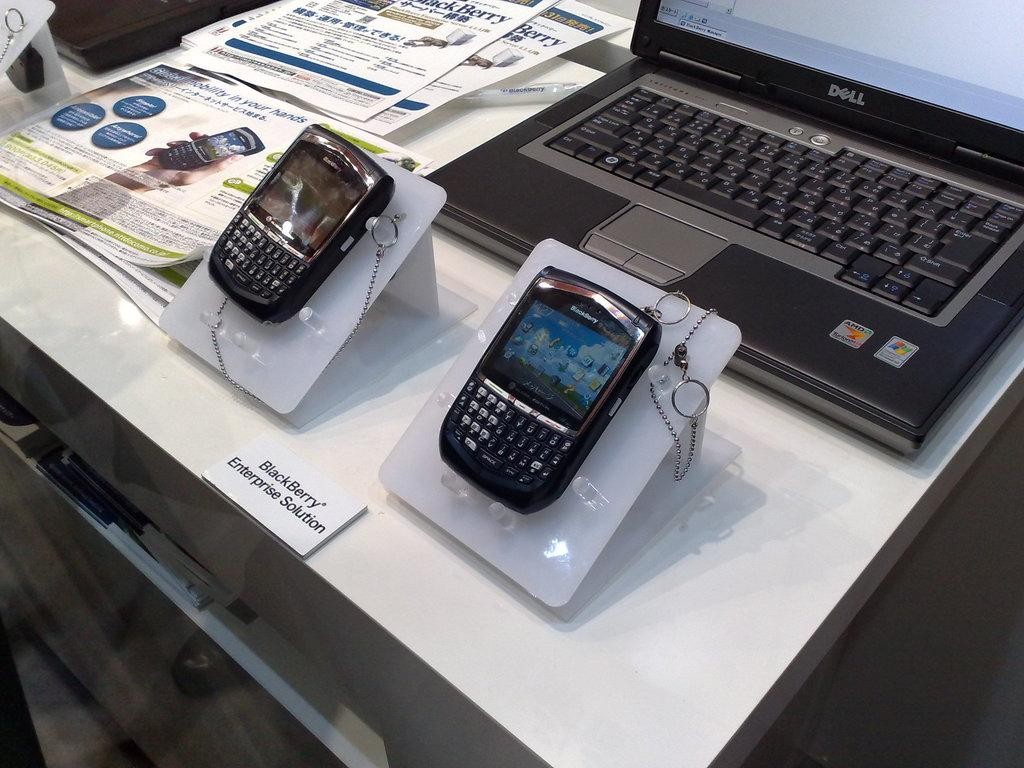<image>
Relay a brief, clear account of the picture shown. Two BlackBerry phones sit on display at the BlackBerry Enterprise Solution desk. 